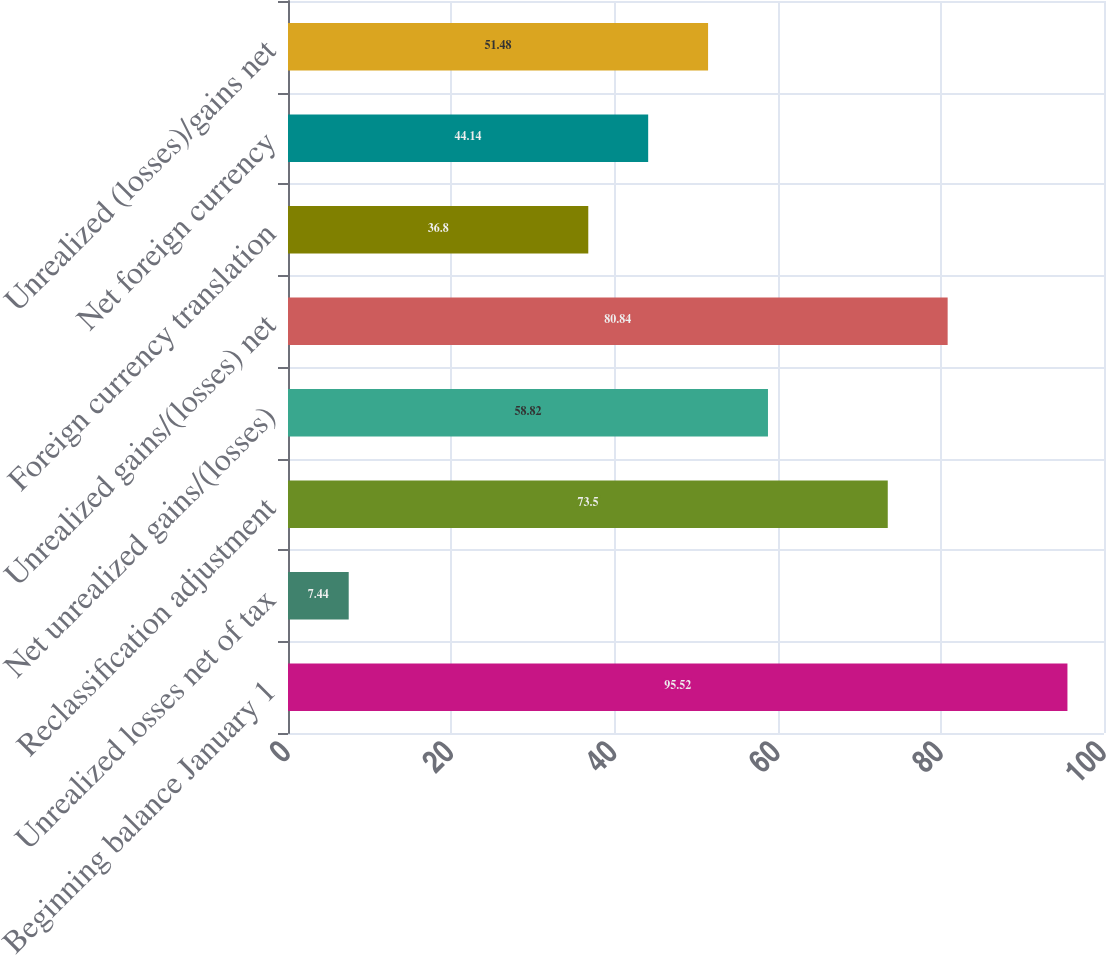<chart> <loc_0><loc_0><loc_500><loc_500><bar_chart><fcel>Beginning balance January 1<fcel>Unrealized losses net of tax<fcel>Reclassification adjustment<fcel>Net unrealized gains/(losses)<fcel>Unrealized gains/(losses) net<fcel>Foreign currency translation<fcel>Net foreign currency<fcel>Unrealized (losses)/gains net<nl><fcel>95.52<fcel>7.44<fcel>73.5<fcel>58.82<fcel>80.84<fcel>36.8<fcel>44.14<fcel>51.48<nl></chart> 